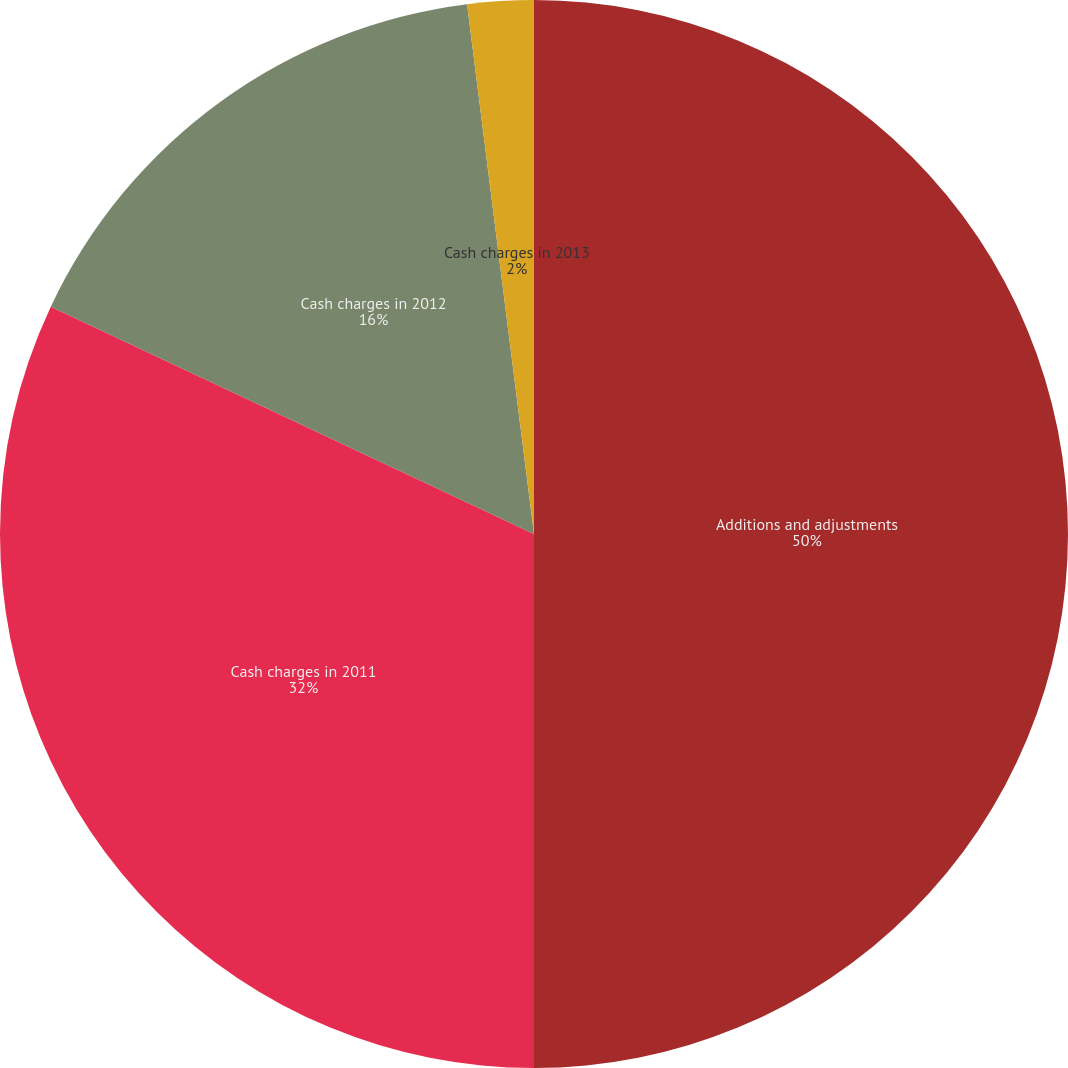<chart> <loc_0><loc_0><loc_500><loc_500><pie_chart><fcel>Additions and adjustments<fcel>Cash charges in 2011<fcel>Cash charges in 2012<fcel>Cash charges in 2013<nl><fcel>50.0%<fcel>32.0%<fcel>16.0%<fcel>2.0%<nl></chart> 